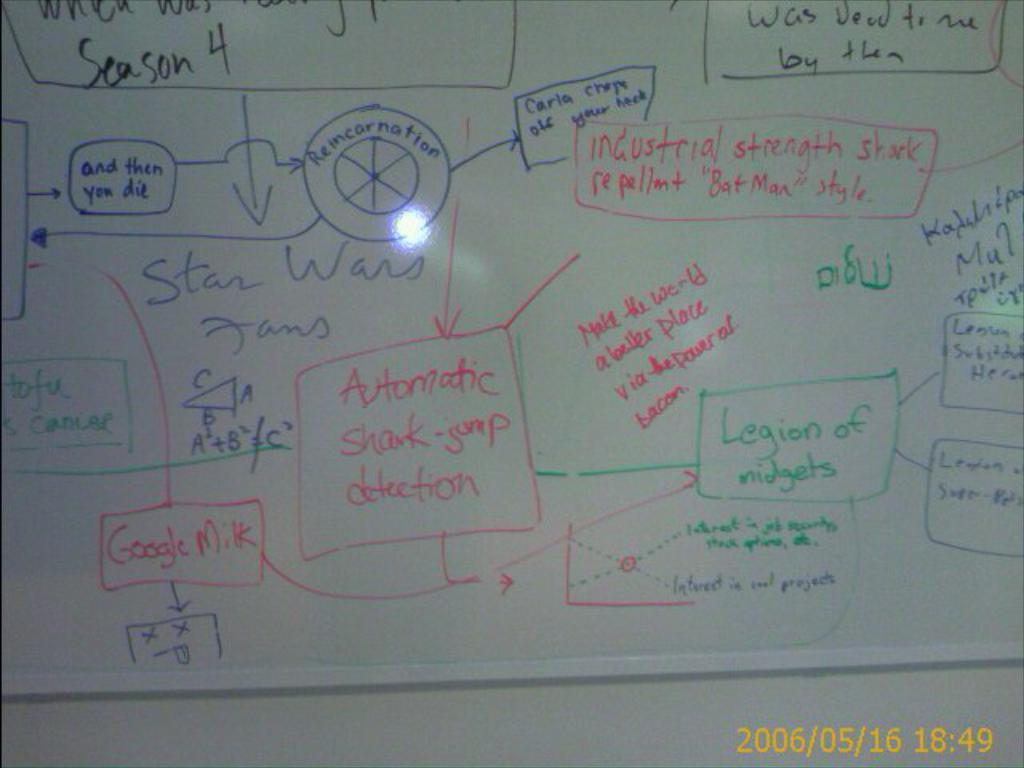<image>
Describe the image concisely. A white board is filled with plans for detecting and repelling sharks. 